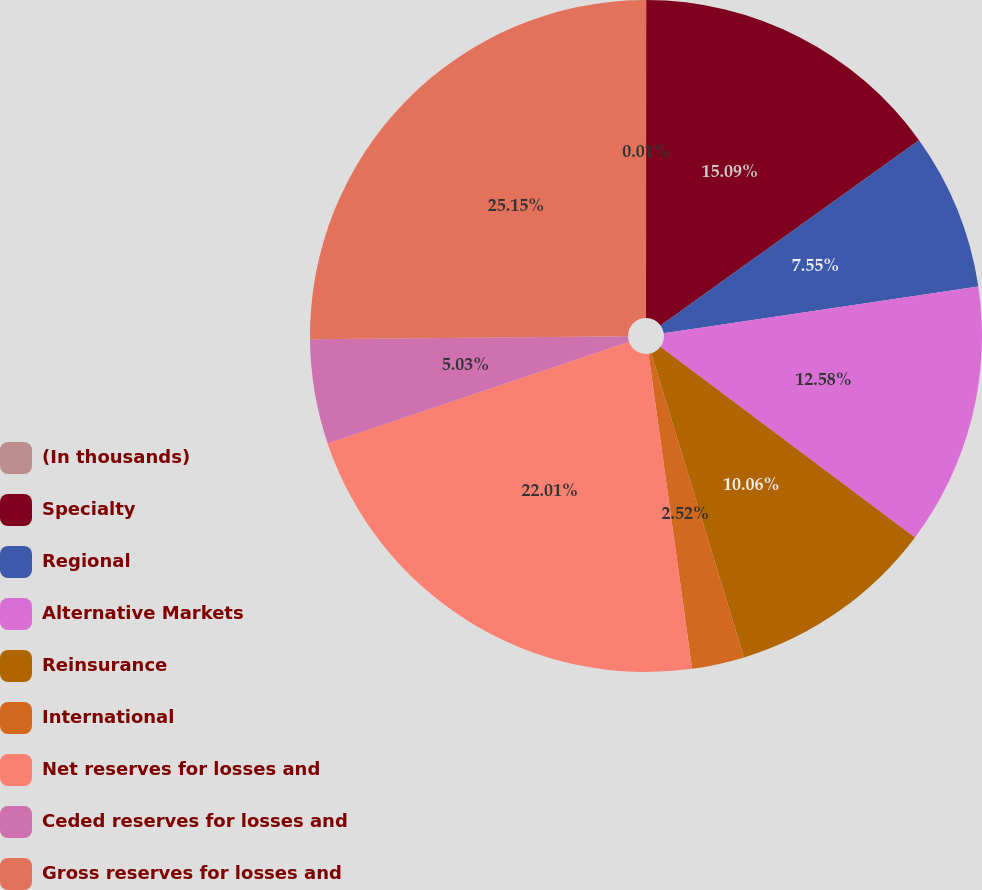<chart> <loc_0><loc_0><loc_500><loc_500><pie_chart><fcel>(In thousands)<fcel>Specialty<fcel>Regional<fcel>Alternative Markets<fcel>Reinsurance<fcel>International<fcel>Net reserves for losses and<fcel>Ceded reserves for losses and<fcel>Gross reserves for losses and<nl><fcel>0.01%<fcel>15.09%<fcel>7.55%<fcel>12.58%<fcel>10.06%<fcel>2.52%<fcel>22.01%<fcel>5.03%<fcel>25.15%<nl></chart> 